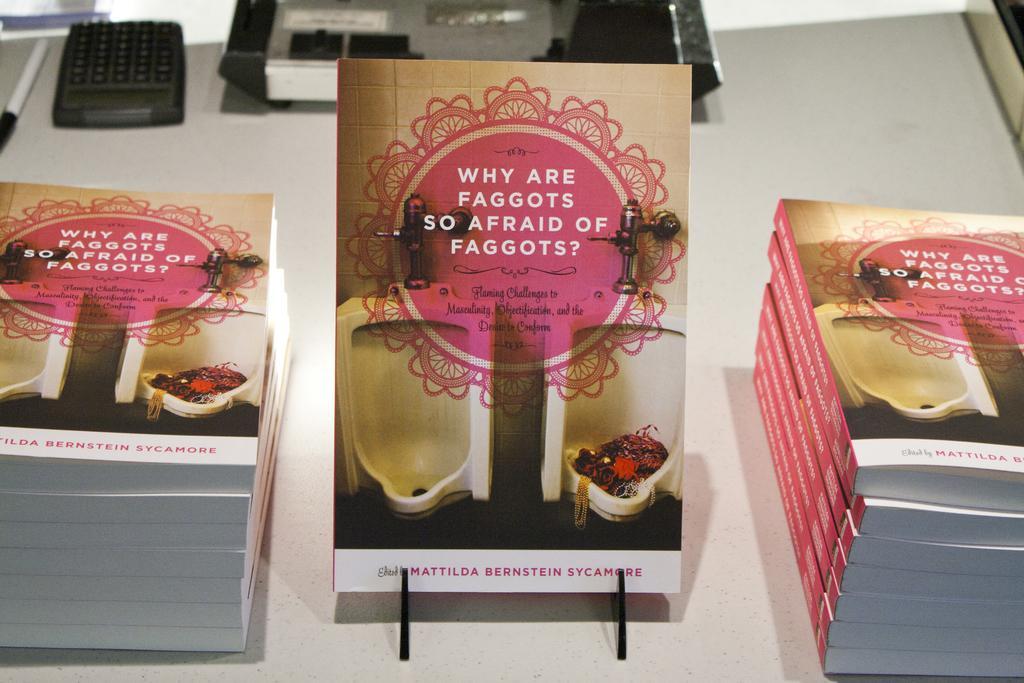Describe this image in one or two sentences. In this image I can see the books, pen and some black color objects. These are on the white color surface. 